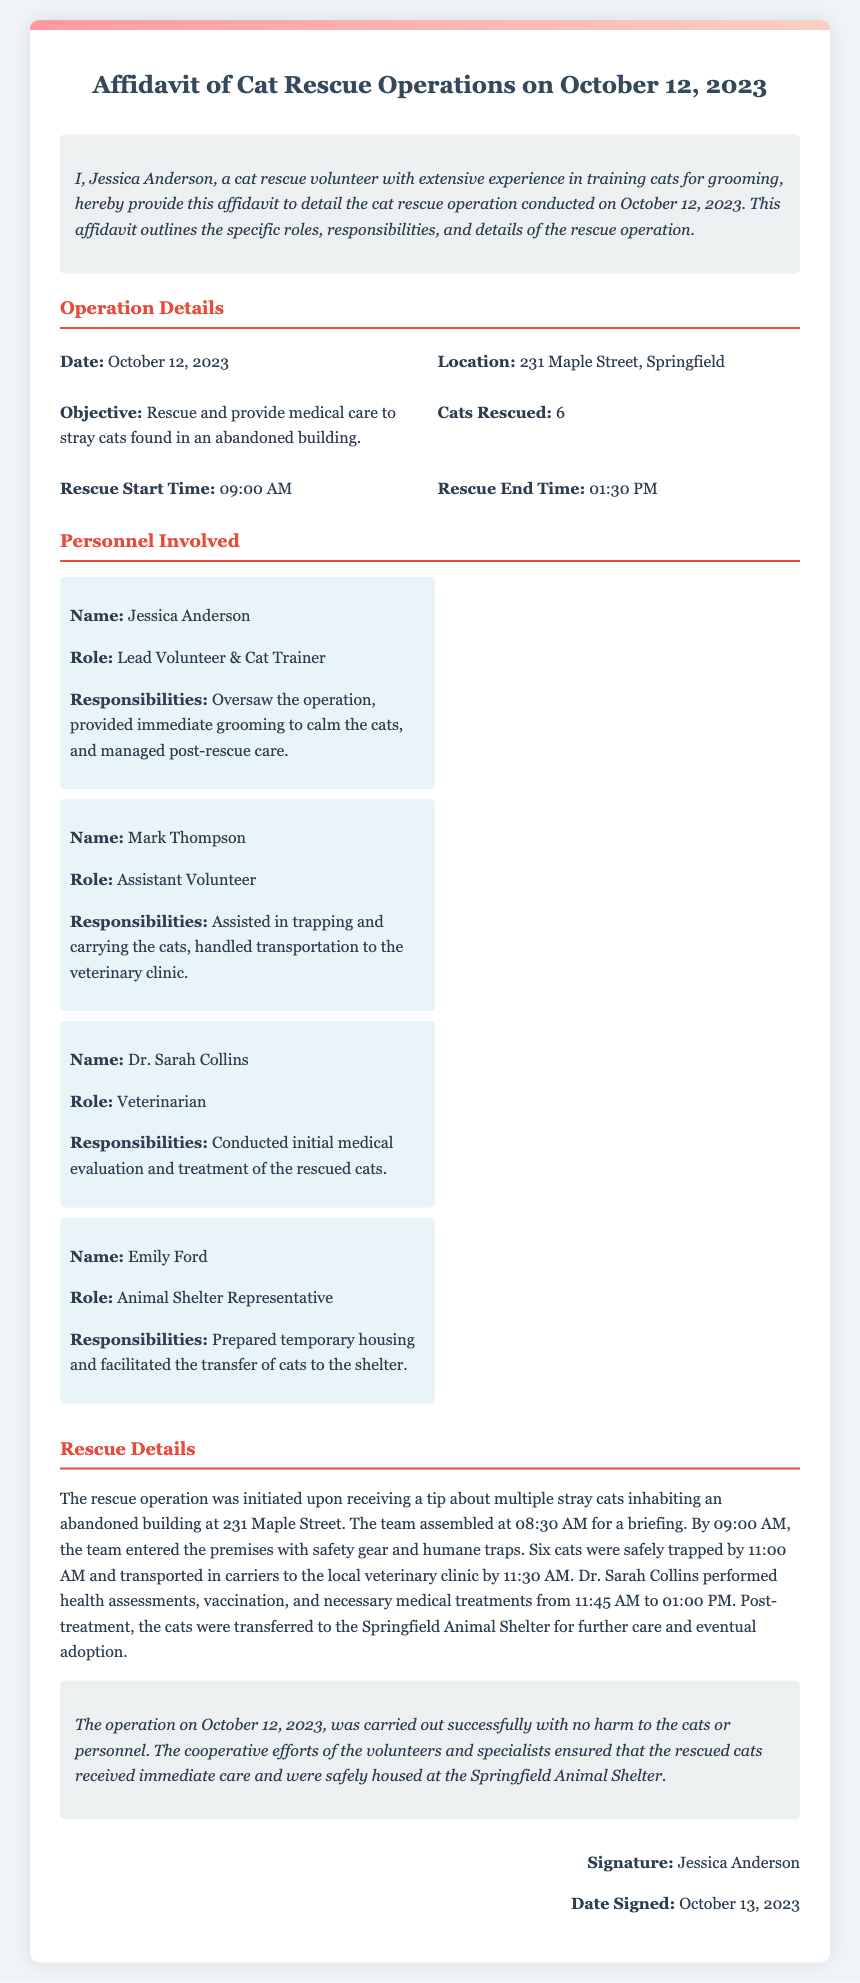What is the date of the rescue operation? The date of the rescue operation is stated at the beginning of the affidavit.
Answer: October 12, 2023 What was the objective of the rescue operation? The objective is mentioned in the Operation Details section of the affidavit.
Answer: Rescue and provide medical care to stray cats found in an abandoned building How many cats were rescued? The number of cats rescued is specified in the Operation Details section of the affidavit.
Answer: 6 Who is the lead volunteer? The name of the lead volunteer is provided in the Personnel Involved section.
Answer: Jessica Anderson What was Mark Thompson’s role? Mark Thompson's role is listed in the Personnel Involved section of the document.
Answer: Assistant Volunteer What time did the rescue operation start? The start time of the rescue operation is stated in the Operation Details section.
Answer: 09:00 AM How long did the vet evaluate the cats? The evaluation duration can be inferred from the times mentioned in the Rescue Details section.
Answer: 1 hour 15 minutes What was the location of the rescue operation? The location is provided in the Operation Details section of the affidavit.
Answer: 231 Maple Street, Springfield What was done with the cats after their treatment? The final destination of the cats after treatment is mentioned in the conclusion.
Answer: Springfield Animal Shelter 